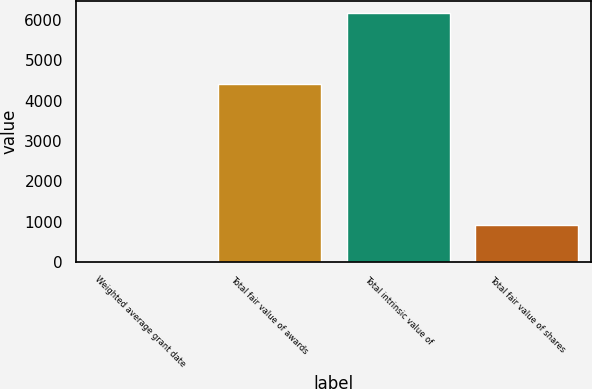Convert chart to OTSL. <chart><loc_0><loc_0><loc_500><loc_500><bar_chart><fcel>Weighted average grant date<fcel>Total fair value of awards<fcel>Total intrinsic value of<fcel>Total fair value of shares<nl><fcel>5.68<fcel>4407<fcel>6170<fcel>923<nl></chart> 